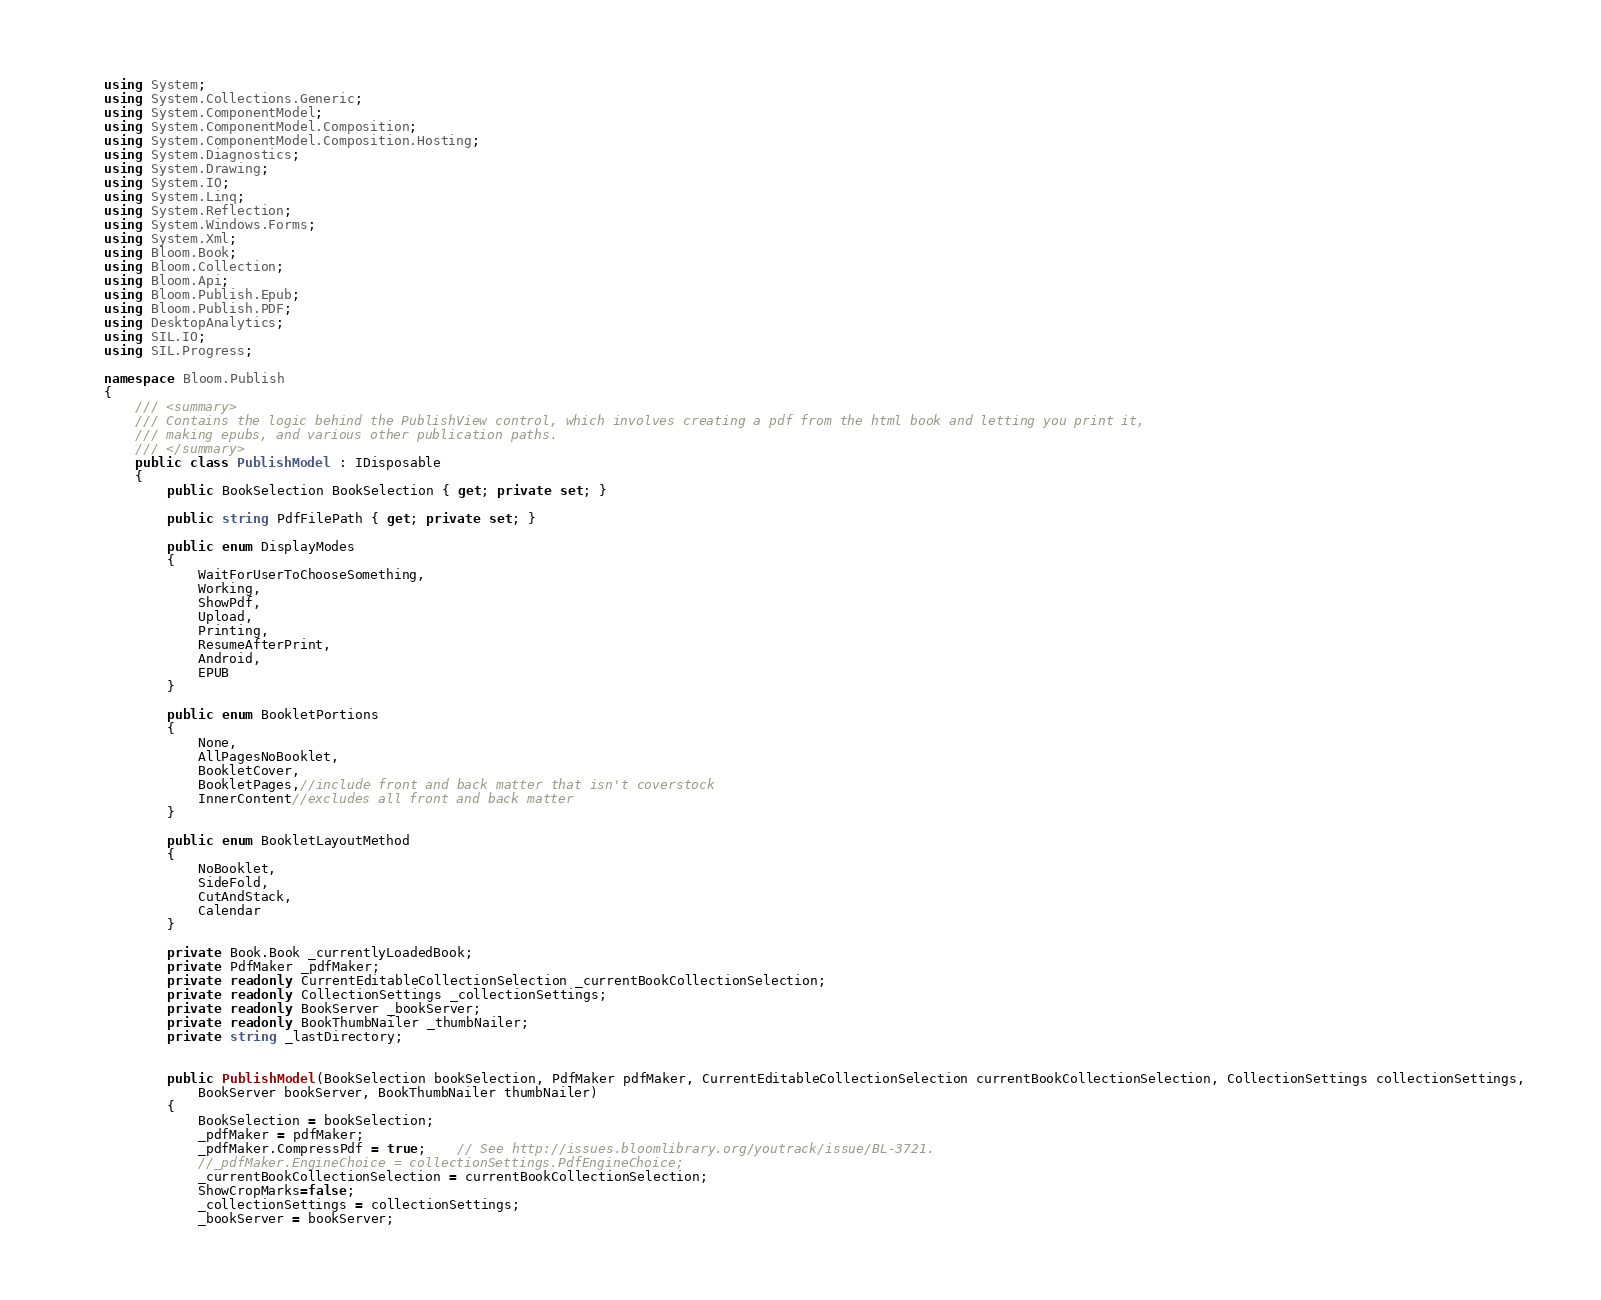<code> <loc_0><loc_0><loc_500><loc_500><_C#_>using System;
using System.Collections.Generic;
using System.ComponentModel;
using System.ComponentModel.Composition;
using System.ComponentModel.Composition.Hosting;
using System.Diagnostics;
using System.Drawing;
using System.IO;
using System.Linq;
using System.Reflection;
using System.Windows.Forms;
using System.Xml;
using Bloom.Book;
using Bloom.Collection;
using Bloom.Api;
using Bloom.Publish.Epub;
using Bloom.Publish.PDF;
using DesktopAnalytics;
using SIL.IO;
using SIL.Progress;

namespace Bloom.Publish
{
	/// <summary>
	/// Contains the logic behind the PublishView control, which involves creating a pdf from the html book and letting you print it,
	/// making epubs, and various other publication paths.
	/// </summary>
	public class PublishModel : IDisposable
	{
		public BookSelection BookSelection { get; private set; }

		public string PdfFilePath { get; private set; }

		public enum DisplayModes
		{
			WaitForUserToChooseSomething,
			Working,
			ShowPdf,
			Upload,
			Printing,
			ResumeAfterPrint,
			Android,
			EPUB
		}

		public enum BookletPortions
		{
			None,
			AllPagesNoBooklet,
			BookletCover,
			BookletPages,//include front and back matter that isn't coverstock
			InnerContent//excludes all front and back matter
		}

		public enum BookletLayoutMethod
		{
			NoBooklet,
			SideFold,
			CutAndStack,
			Calendar
		}

		private Book.Book _currentlyLoadedBook;
		private PdfMaker _pdfMaker;
		private readonly CurrentEditableCollectionSelection _currentBookCollectionSelection;
		private readonly CollectionSettings _collectionSettings;
		private readonly BookServer _bookServer;
		private readonly BookThumbNailer _thumbNailer;
		private string _lastDirectory;


		public PublishModel(BookSelection bookSelection, PdfMaker pdfMaker, CurrentEditableCollectionSelection currentBookCollectionSelection, CollectionSettings collectionSettings,
			BookServer bookServer, BookThumbNailer thumbNailer)
		{
			BookSelection = bookSelection;
			_pdfMaker = pdfMaker;
			_pdfMaker.CompressPdf = true;	// See http://issues.bloomlibrary.org/youtrack/issue/BL-3721.
			//_pdfMaker.EngineChoice = collectionSettings.PdfEngineChoice;
			_currentBookCollectionSelection = currentBookCollectionSelection;
			ShowCropMarks=false;
			_collectionSettings = collectionSettings;
			_bookServer = bookServer;</code> 